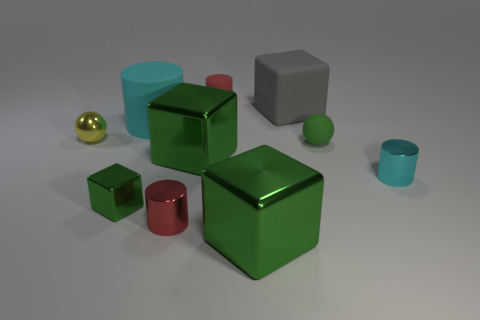Subtract all blue spheres. How many green blocks are left? 3 Subtract 1 blocks. How many blocks are left? 3 Subtract all blocks. How many objects are left? 6 Add 3 small green objects. How many small green objects are left? 5 Add 8 small cyan metallic things. How many small cyan metallic things exist? 9 Subtract 0 cyan blocks. How many objects are left? 10 Subtract all green matte spheres. Subtract all tiny metal cylinders. How many objects are left? 7 